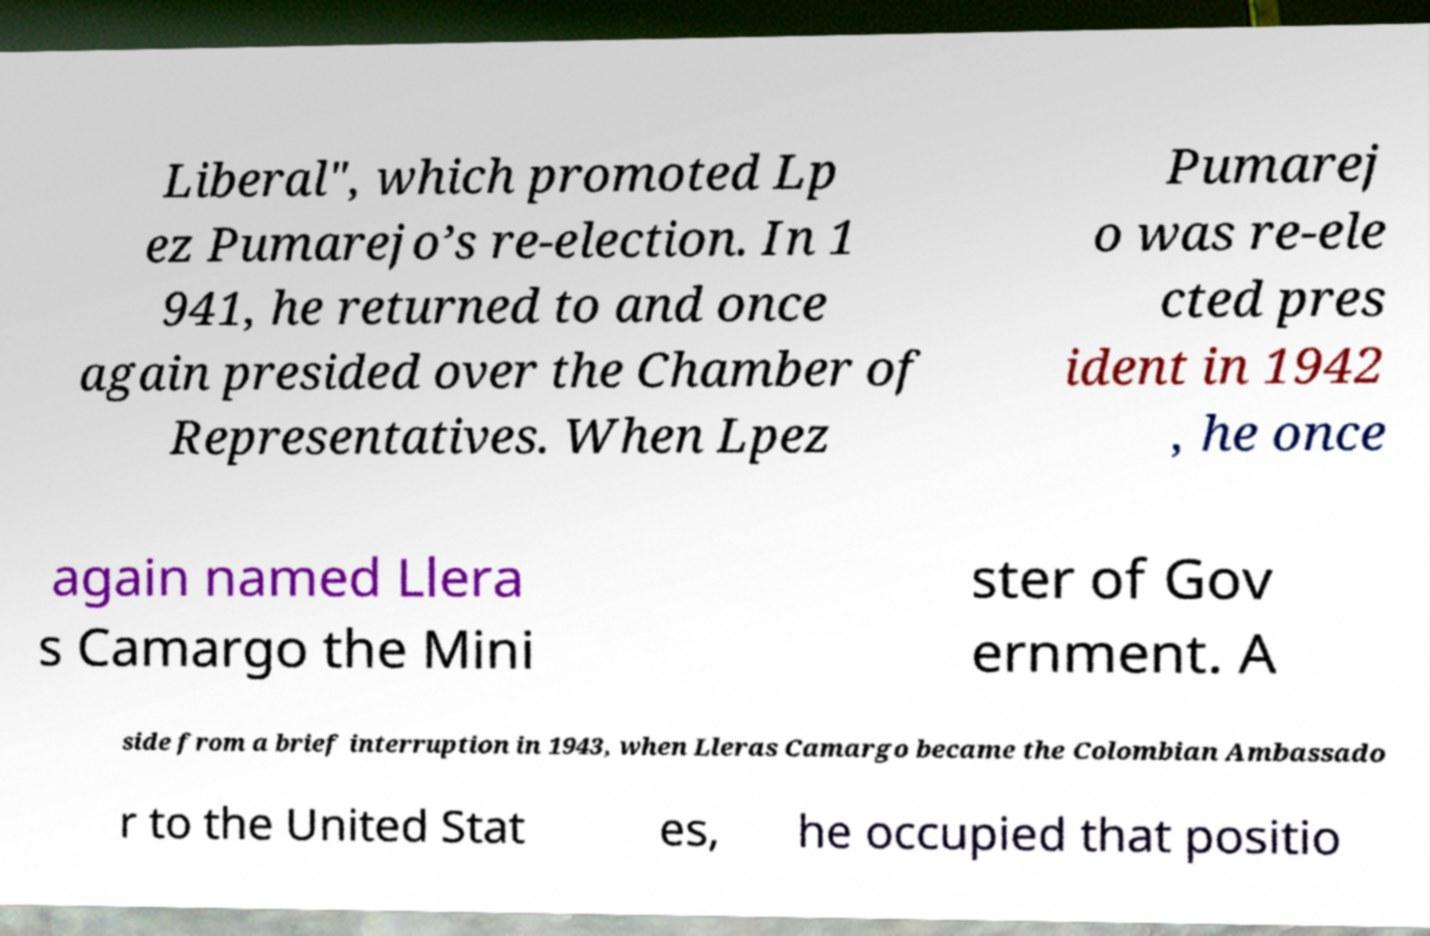Can you read and provide the text displayed in the image?This photo seems to have some interesting text. Can you extract and type it out for me? Liberal", which promoted Lp ez Pumarejo’s re-election. In 1 941, he returned to and once again presided over the Chamber of Representatives. When Lpez Pumarej o was re-ele cted pres ident in 1942 , he once again named Llera s Camargo the Mini ster of Gov ernment. A side from a brief interruption in 1943, when Lleras Camargo became the Colombian Ambassado r to the United Stat es, he occupied that positio 